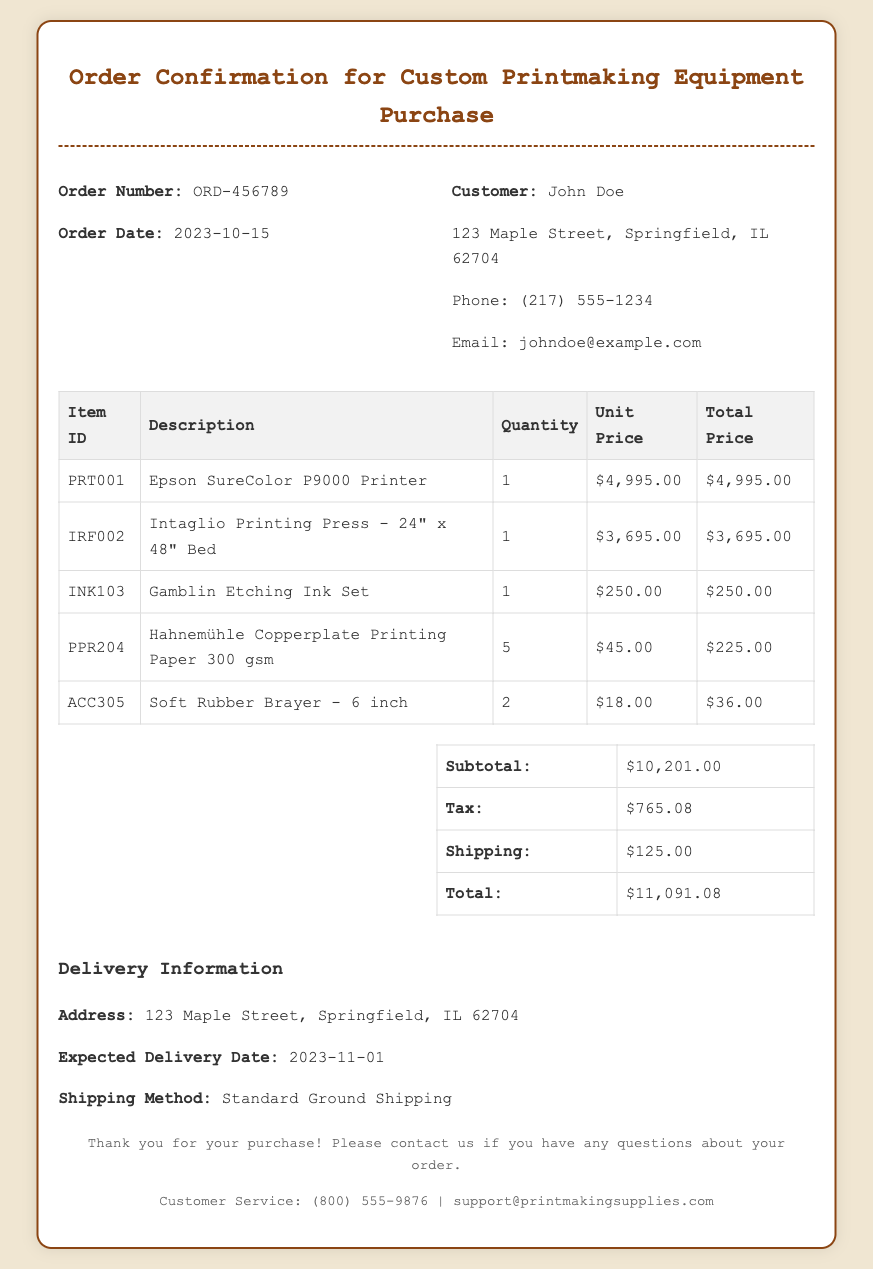What is the order number? The order number is located in the document under "Order Number," which is ORD-456789.
Answer: ORD-456789 When was the order placed? The order date is provided in the document, indicated as 2023-10-15.
Answer: 2023-10-15 What is the total price of the order? The total price is calculated from the summary section of the document, which shows a total of $11,091.08.
Answer: $11,091.08 Who is the customer? The customer's name is mentioned in the customer details section, which is John Doe.
Answer: John Doe What is the expected delivery date? The expected delivery date is listed under delivery information, which states 2023-11-01.
Answer: 2023-11-01 What shipping method will be used? The shipping method is specified in the delivery information as Standard Ground Shipping.
Answer: Standard Ground Shipping How many items were ordered in total? The number of items can be derived by counting the entries in the itemized list; there are 5 items ordered.
Answer: 5 What is the subtotal of the order? The subtotal is the amount listed in the summary section, which is $10,201.00.
Answer: $10,201.00 Where should the items be delivered? The delivery address is provided in the delivery information, which lists 123 Maple Street, Springfield, IL 62704.
Answer: 123 Maple Street, Springfield, IL 62704 